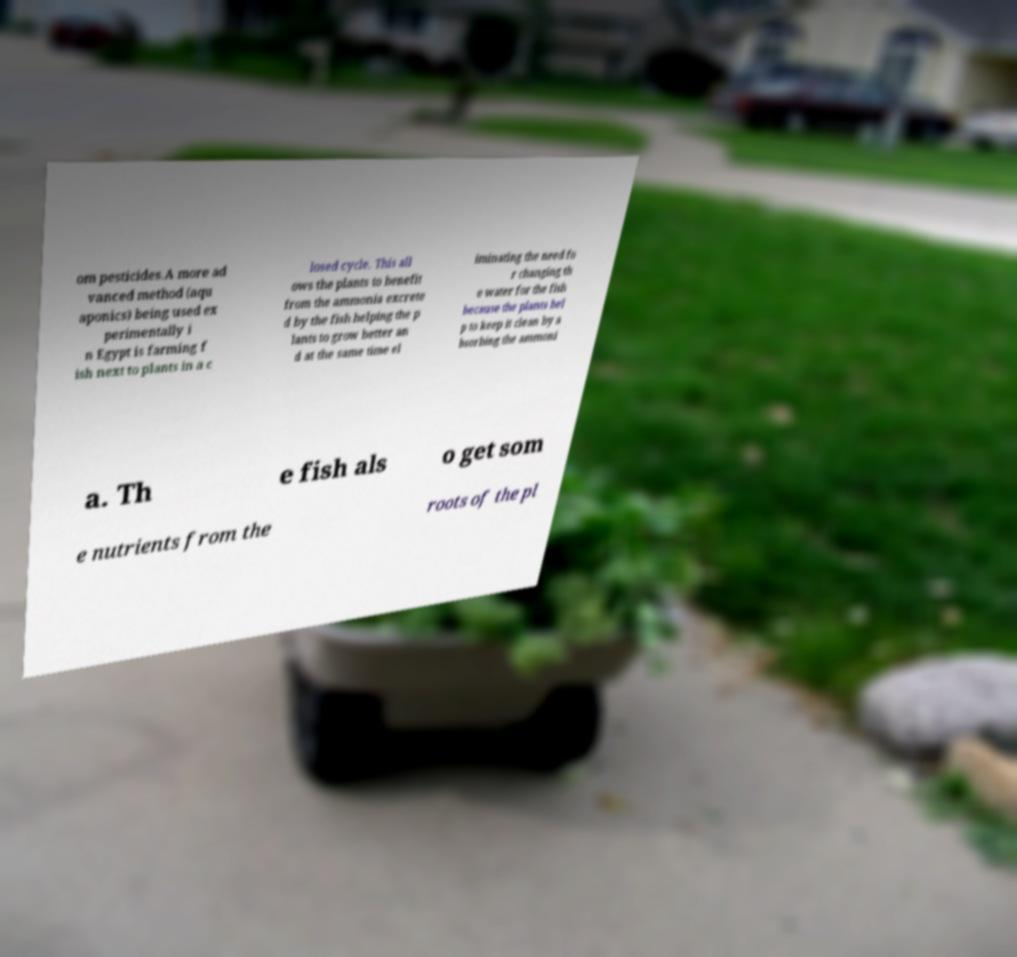What messages or text are displayed in this image? I need them in a readable, typed format. om pesticides.A more ad vanced method (aqu aponics) being used ex perimentally i n Egypt is farming f ish next to plants in a c losed cycle. This all ows the plants to benefit from the ammonia excrete d by the fish helping the p lants to grow better an d at the same time el iminating the need fo r changing th e water for the fish because the plants hel p to keep it clean by a bsorbing the ammoni a. Th e fish als o get som e nutrients from the roots of the pl 